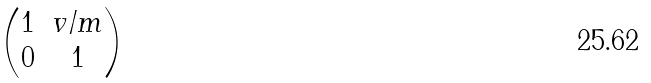Convert formula to latex. <formula><loc_0><loc_0><loc_500><loc_500>\begin{pmatrix} 1 & v / m \\ 0 & 1 \end{pmatrix}</formula> 